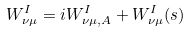<formula> <loc_0><loc_0><loc_500><loc_500>W ^ { I } _ { \nu \mu } = i W _ { \nu \mu , A } ^ { I } + W _ { \nu \mu } ^ { I } ( s )</formula> 